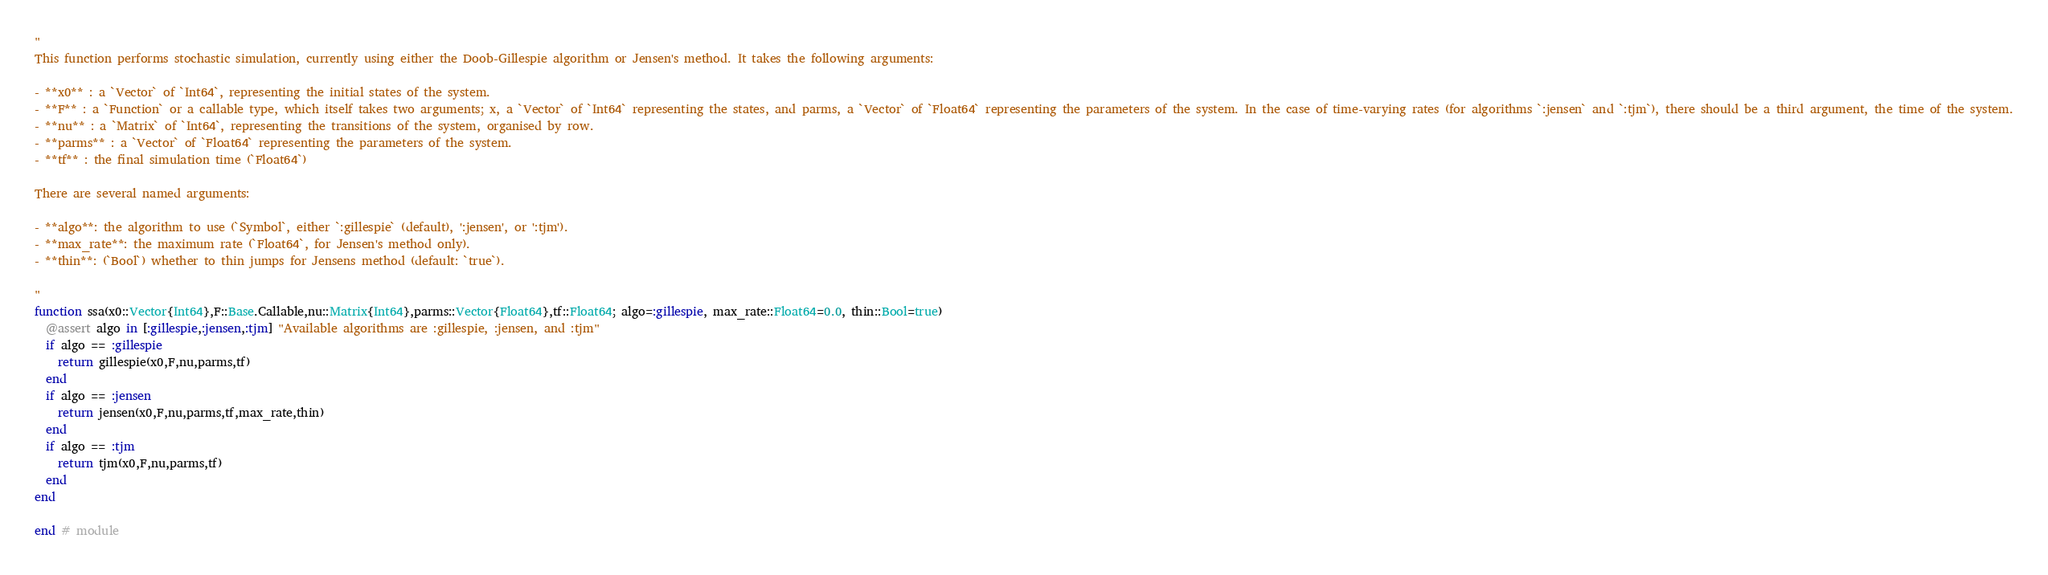Convert code to text. <code><loc_0><loc_0><loc_500><loc_500><_Julia_>"
This function performs stochastic simulation, currently using either the Doob-Gillespie algorithm or Jensen's method. It takes the following arguments:

- **x0** : a `Vector` of `Int64`, representing the initial states of the system.
- **F** : a `Function` or a callable type, which itself takes two arguments; x, a `Vector` of `Int64` representing the states, and parms, a `Vector` of `Float64` representing the parameters of the system. In the case of time-varying rates (for algorithms `:jensen` and `:tjm`), there should be a third argument, the time of the system.
- **nu** : a `Matrix` of `Int64`, representing the transitions of the system, organised by row.
- **parms** : a `Vector` of `Float64` representing the parameters of the system.
- **tf** : the final simulation time (`Float64`)

There are several named arguments:

- **algo**: the algorithm to use (`Symbol`, either `:gillespie` (default), ':jensen', or ':tjm').
- **max_rate**: the maximum rate (`Float64`, for Jensen's method only).
- **thin**: (`Bool`) whether to thin jumps for Jensens method (default: `true`).

"
function ssa(x0::Vector{Int64},F::Base.Callable,nu::Matrix{Int64},parms::Vector{Float64},tf::Float64; algo=:gillespie, max_rate::Float64=0.0, thin::Bool=true)
  @assert algo in [:gillespie,:jensen,:tjm] "Available algorithms are :gillespie, :jensen, and :tjm"
  if algo == :gillespie
    return gillespie(x0,F,nu,parms,tf)
  end
  if algo == :jensen
    return jensen(x0,F,nu,parms,tf,max_rate,thin)
  end
  if algo == :tjm
    return tjm(x0,F,nu,parms,tf)
  end
end

end # module
</code> 